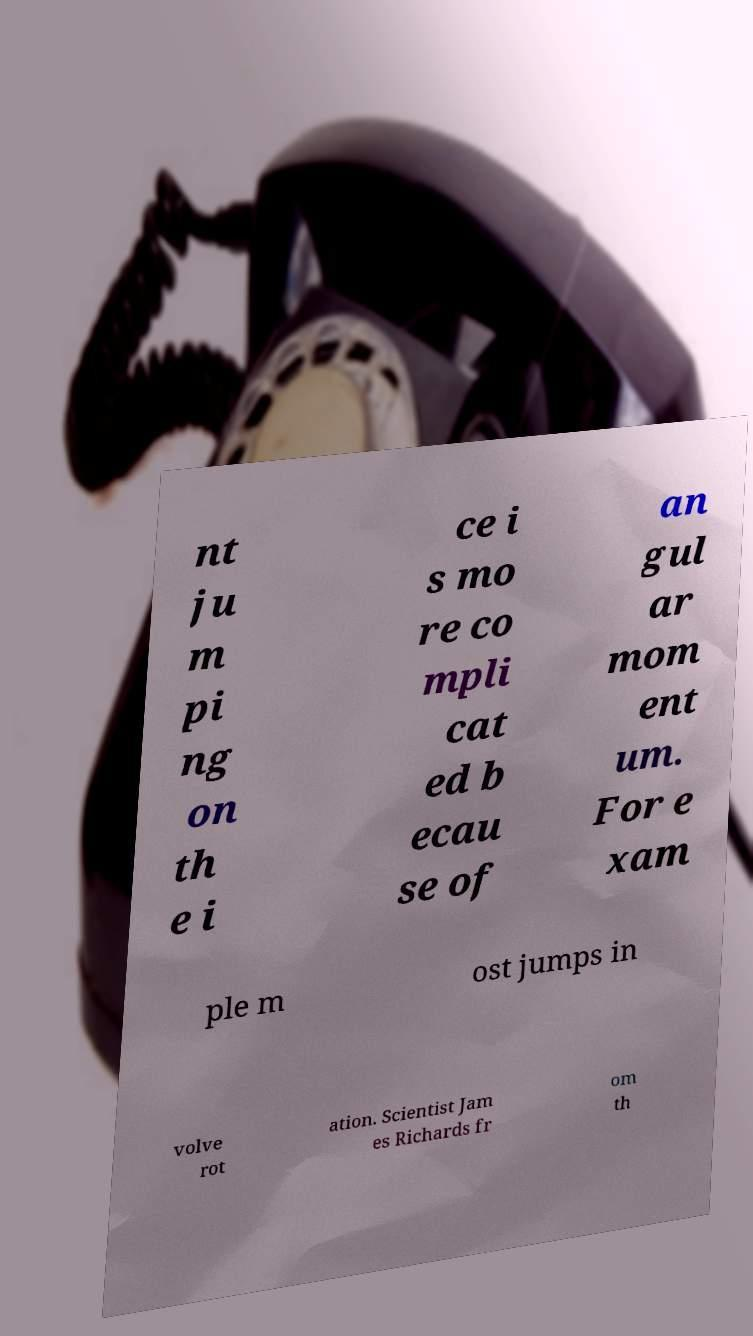I need the written content from this picture converted into text. Can you do that? nt ju m pi ng on th e i ce i s mo re co mpli cat ed b ecau se of an gul ar mom ent um. For e xam ple m ost jumps in volve rot ation. Scientist Jam es Richards fr om th 